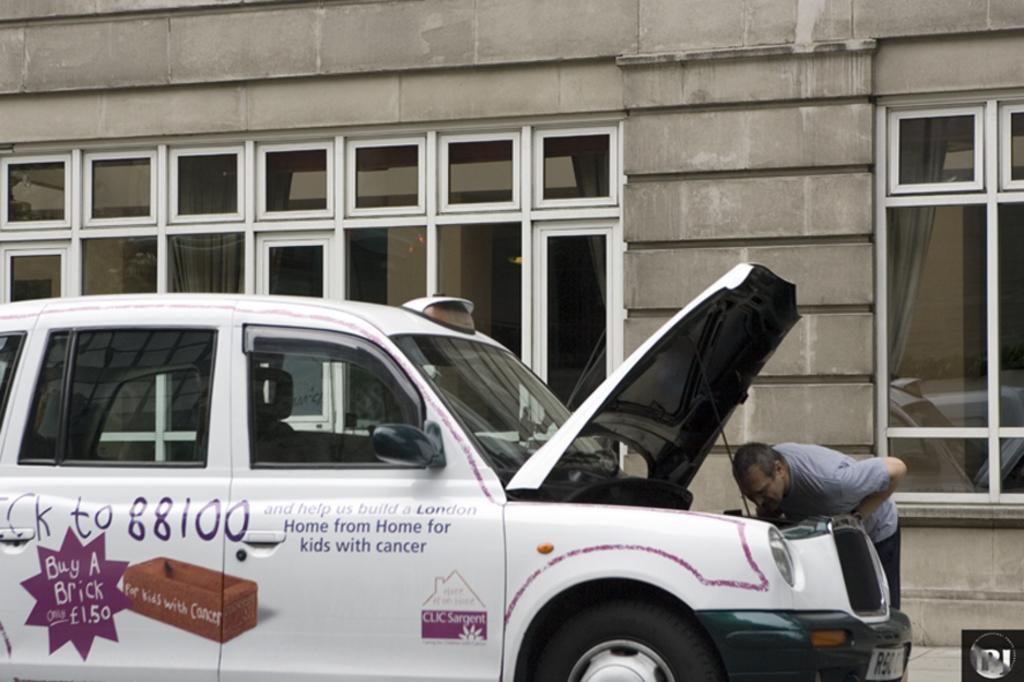Provide a one-sentence caption for the provided image. A man leans to look under the hood of a vehicle that has a promotion to buy a brick for cancer victims on its side. 